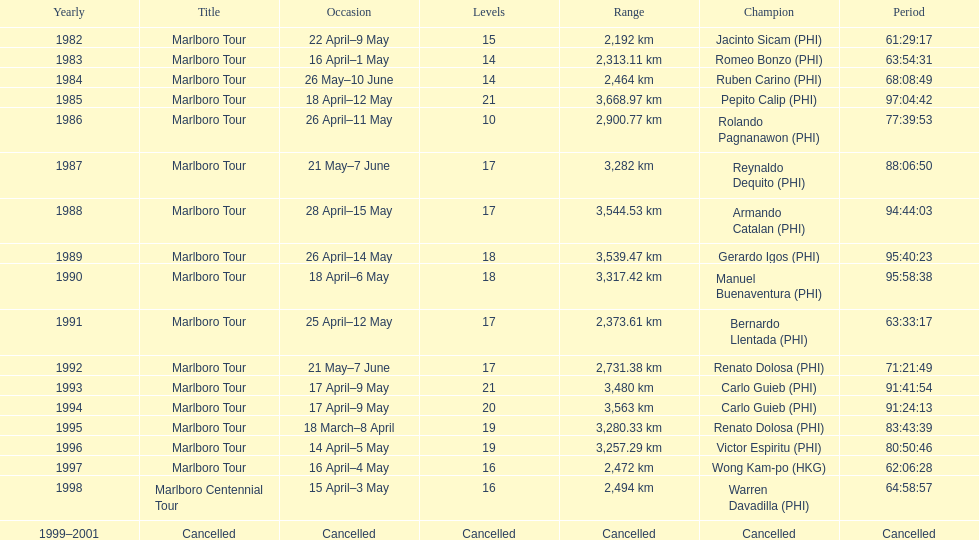How many marlboro tours did carlo guieb win? 2. 